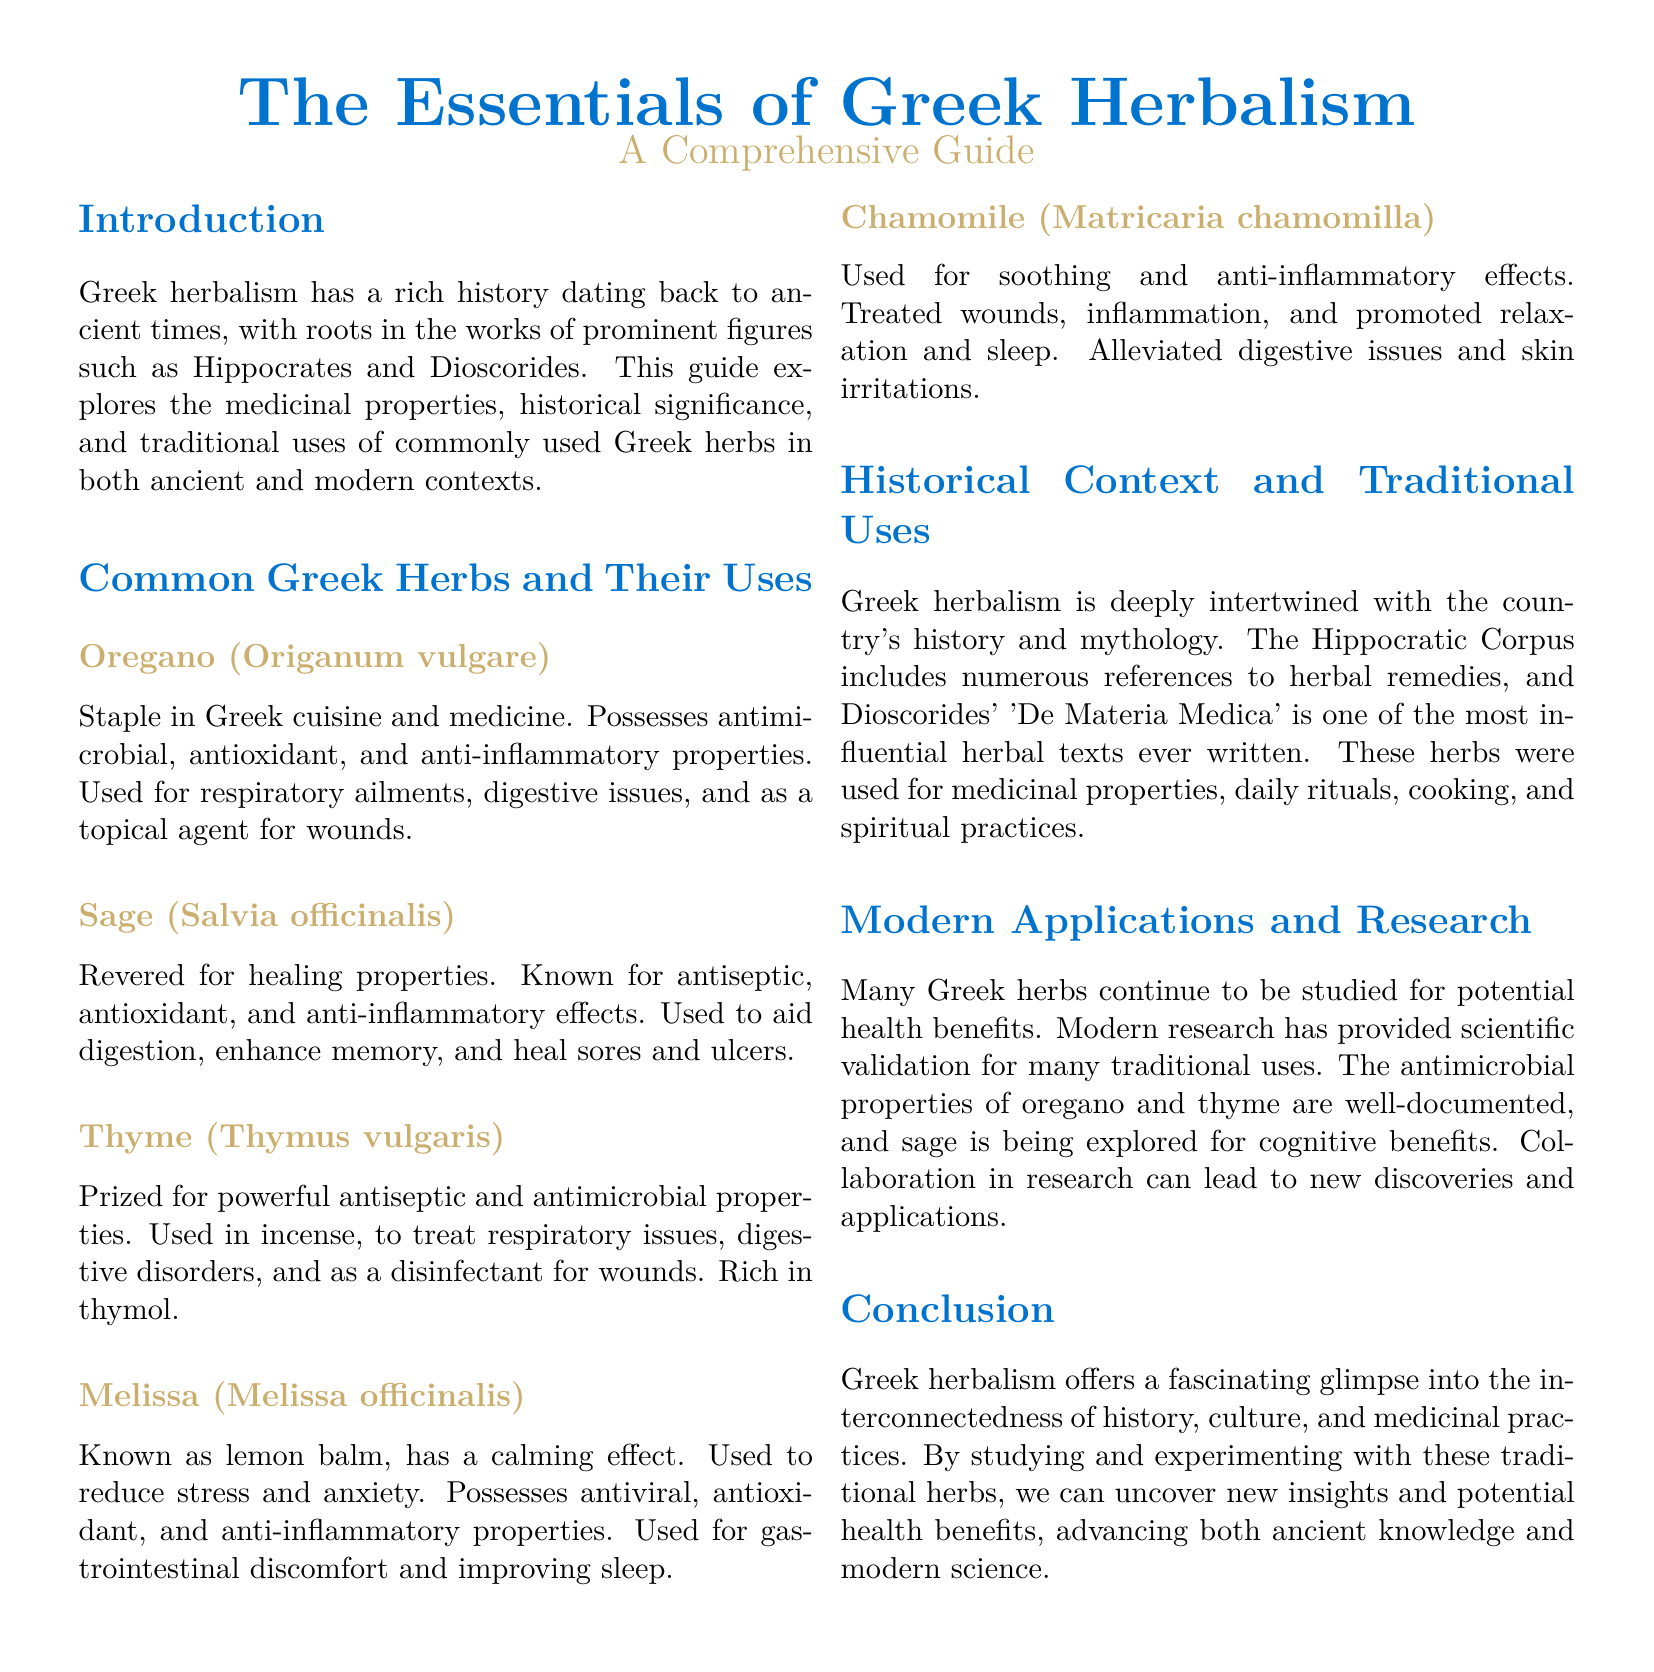What is the initial herb mentioned in the guide? The guide starts by discussing Oregano, the first herb listed in the section on common Greek herbs.
Answer: Oregano (Origanum vulgare) What historical figure is associated with the beginnings of Greek herbalism? Hippocrates is mentioned in the introduction as a prominent figure in the history of Greek herbalism.
Answer: Hippocrates What is one property of Sage listed in the document? The document states that Sage has antiseptic properties among others.
Answer: Antiseptic Which herb is known as lemon balm? The guide refers to Melissa as lemon balm in the description of its uses.
Answer: Melissa Name one traditional use of Chamomile mentioned in the guide. The document lists promoting relaxation and sleep as a traditional use of Chamomile.
Answer: Promoted relaxation and sleep What aspect of Greek herbalism is emphasized in the conclusion? The conclusion emphasizes the interconnectedness of history, culture, and medicinal practices in Greek herbalism.
Answer: Interconnectedness of history, culture, and medicinal practices What modern application is currently being researched concerning Sage? Cognitive benefits of Sage are being explored in modern research according to the document.
Answer: Cognitive benefits How many common Greek herbs are described in the guide? The guide details five common Greek herbs under the pertinent section.
Answer: Five 